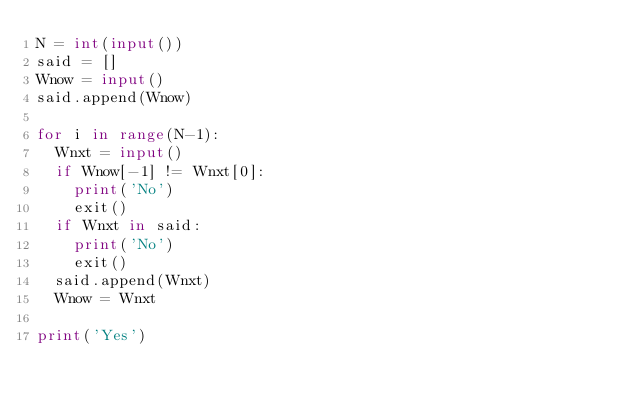Convert code to text. <code><loc_0><loc_0><loc_500><loc_500><_Python_>N = int(input())
said = []
Wnow = input()
said.append(Wnow)

for i in range(N-1):
  Wnxt = input()
  if Wnow[-1] != Wnxt[0]:
    print('No')
    exit()
  if Wnxt in said:
    print('No')
    exit()
  said.append(Wnxt)
  Wnow = Wnxt
  
print('Yes')
  </code> 